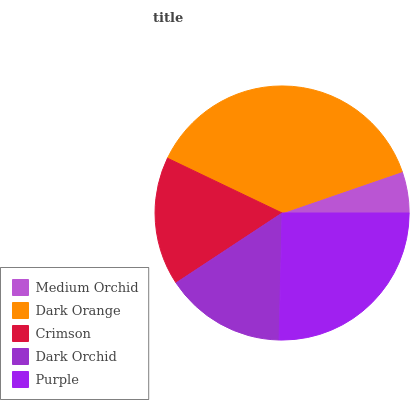Is Medium Orchid the minimum?
Answer yes or no. Yes. Is Dark Orange the maximum?
Answer yes or no. Yes. Is Crimson the minimum?
Answer yes or no. No. Is Crimson the maximum?
Answer yes or no. No. Is Dark Orange greater than Crimson?
Answer yes or no. Yes. Is Crimson less than Dark Orange?
Answer yes or no. Yes. Is Crimson greater than Dark Orange?
Answer yes or no. No. Is Dark Orange less than Crimson?
Answer yes or no. No. Is Crimson the high median?
Answer yes or no. Yes. Is Crimson the low median?
Answer yes or no. Yes. Is Purple the high median?
Answer yes or no. No. Is Medium Orchid the low median?
Answer yes or no. No. 